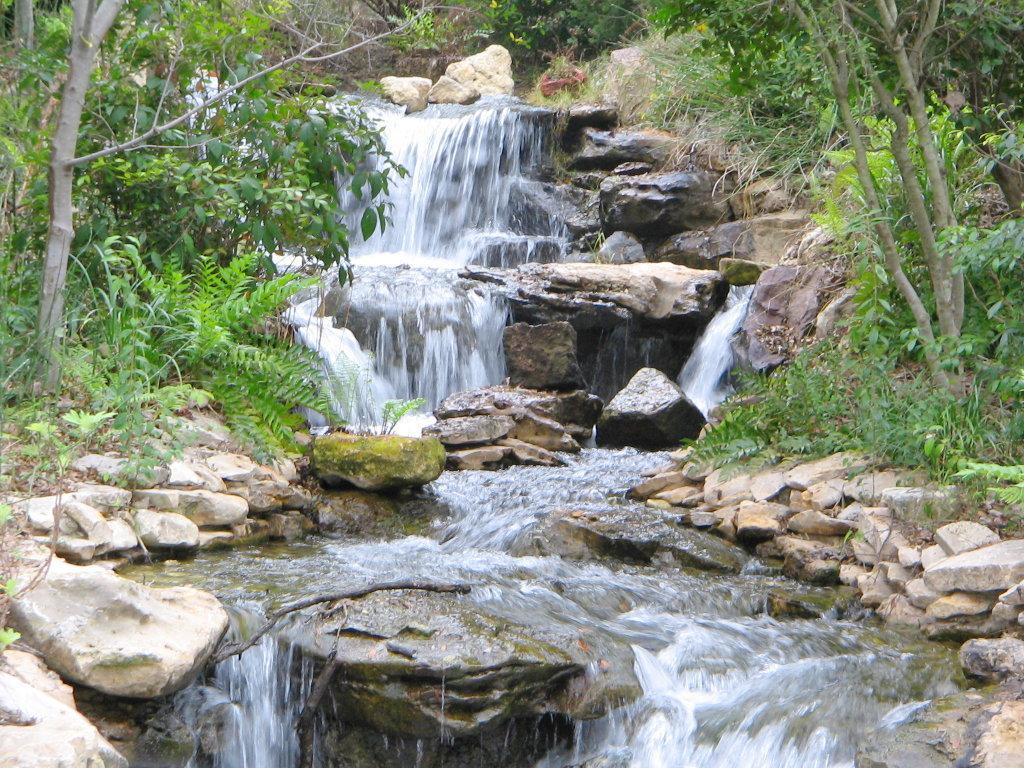How would you summarize this image in a sentence or two? In the center of the image we can see trees, grass, water and rocks. 